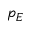<formula> <loc_0><loc_0><loc_500><loc_500>p _ { E }</formula> 